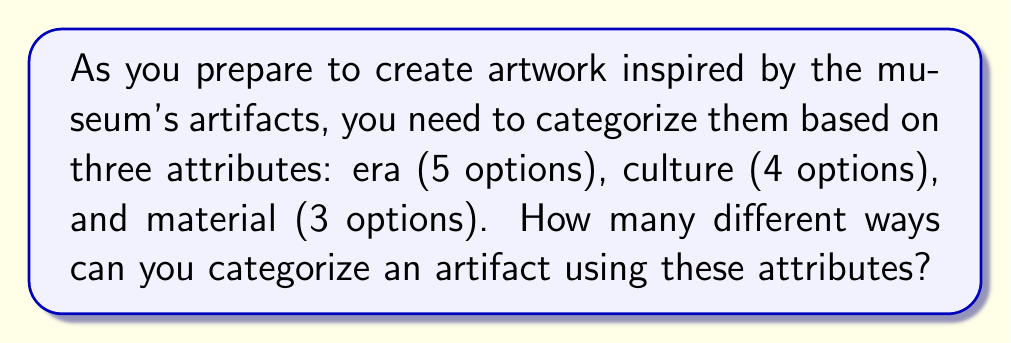Can you answer this question? Let's approach this step-by-step using the multiplication principle of counting:

1) For each artifact, we need to choose one option from each attribute:
   - Era: 5 options
   - Culture: 4 options
   - Material: 3 options

2) According to the multiplication principle, if we have a series of independent choices, the total number of possible outcomes is the product of the number of possibilities for each choice.

3) In this case, for each artifact, we have:
   - 5 choices for era
   - 4 choices for culture
   - 3 choices for material

4) Therefore, the total number of ways to categorize an artifact is:

   $$5 \times 4 \times 3 = 60$$

5) This means that each artifact can be placed into one of 60 distinct categories based on these three attributes.

For example, one category might be "Ancient Era, Greek Culture, Stone Material", while another might be "Modern Era, Egyptian Culture, Metal Material".
Answer: 60 